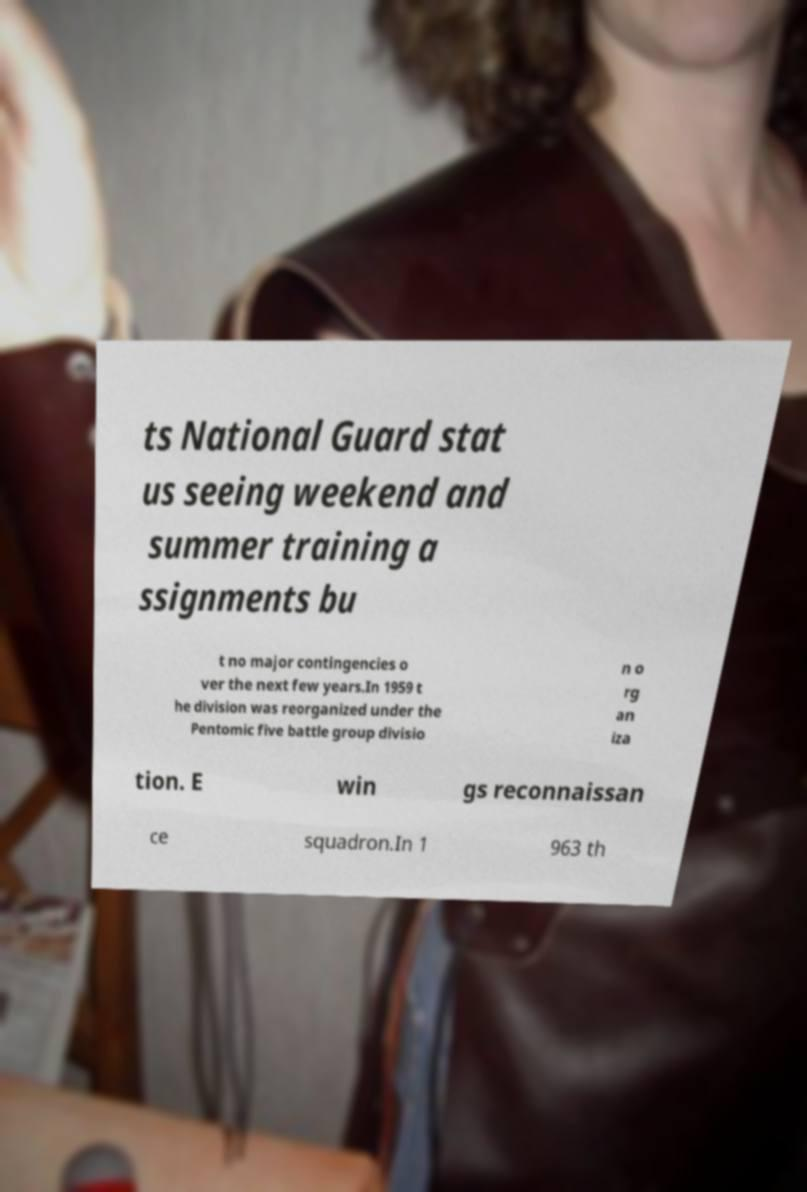Could you assist in decoding the text presented in this image and type it out clearly? ts National Guard stat us seeing weekend and summer training a ssignments bu t no major contingencies o ver the next few years.In 1959 t he division was reorganized under the Pentomic five battle group divisio n o rg an iza tion. E win gs reconnaissan ce squadron.In 1 963 th 